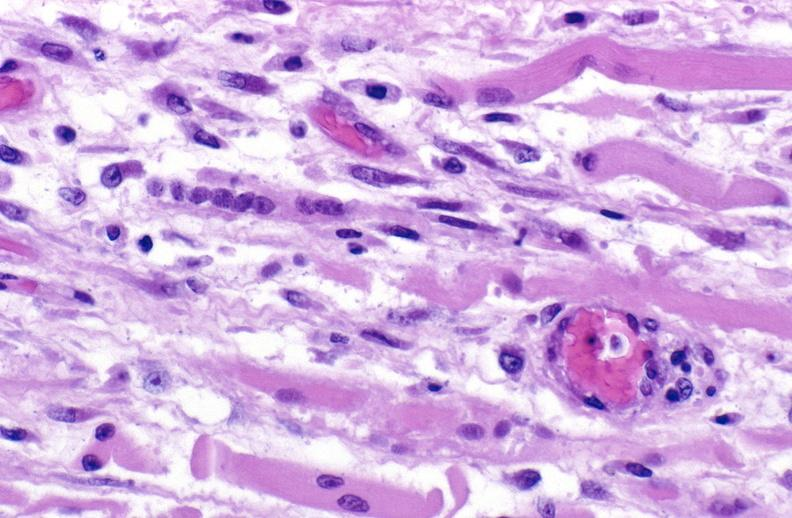does nuclear change show tracheotomy site, granulation tissue?
Answer the question using a single word or phrase. No 